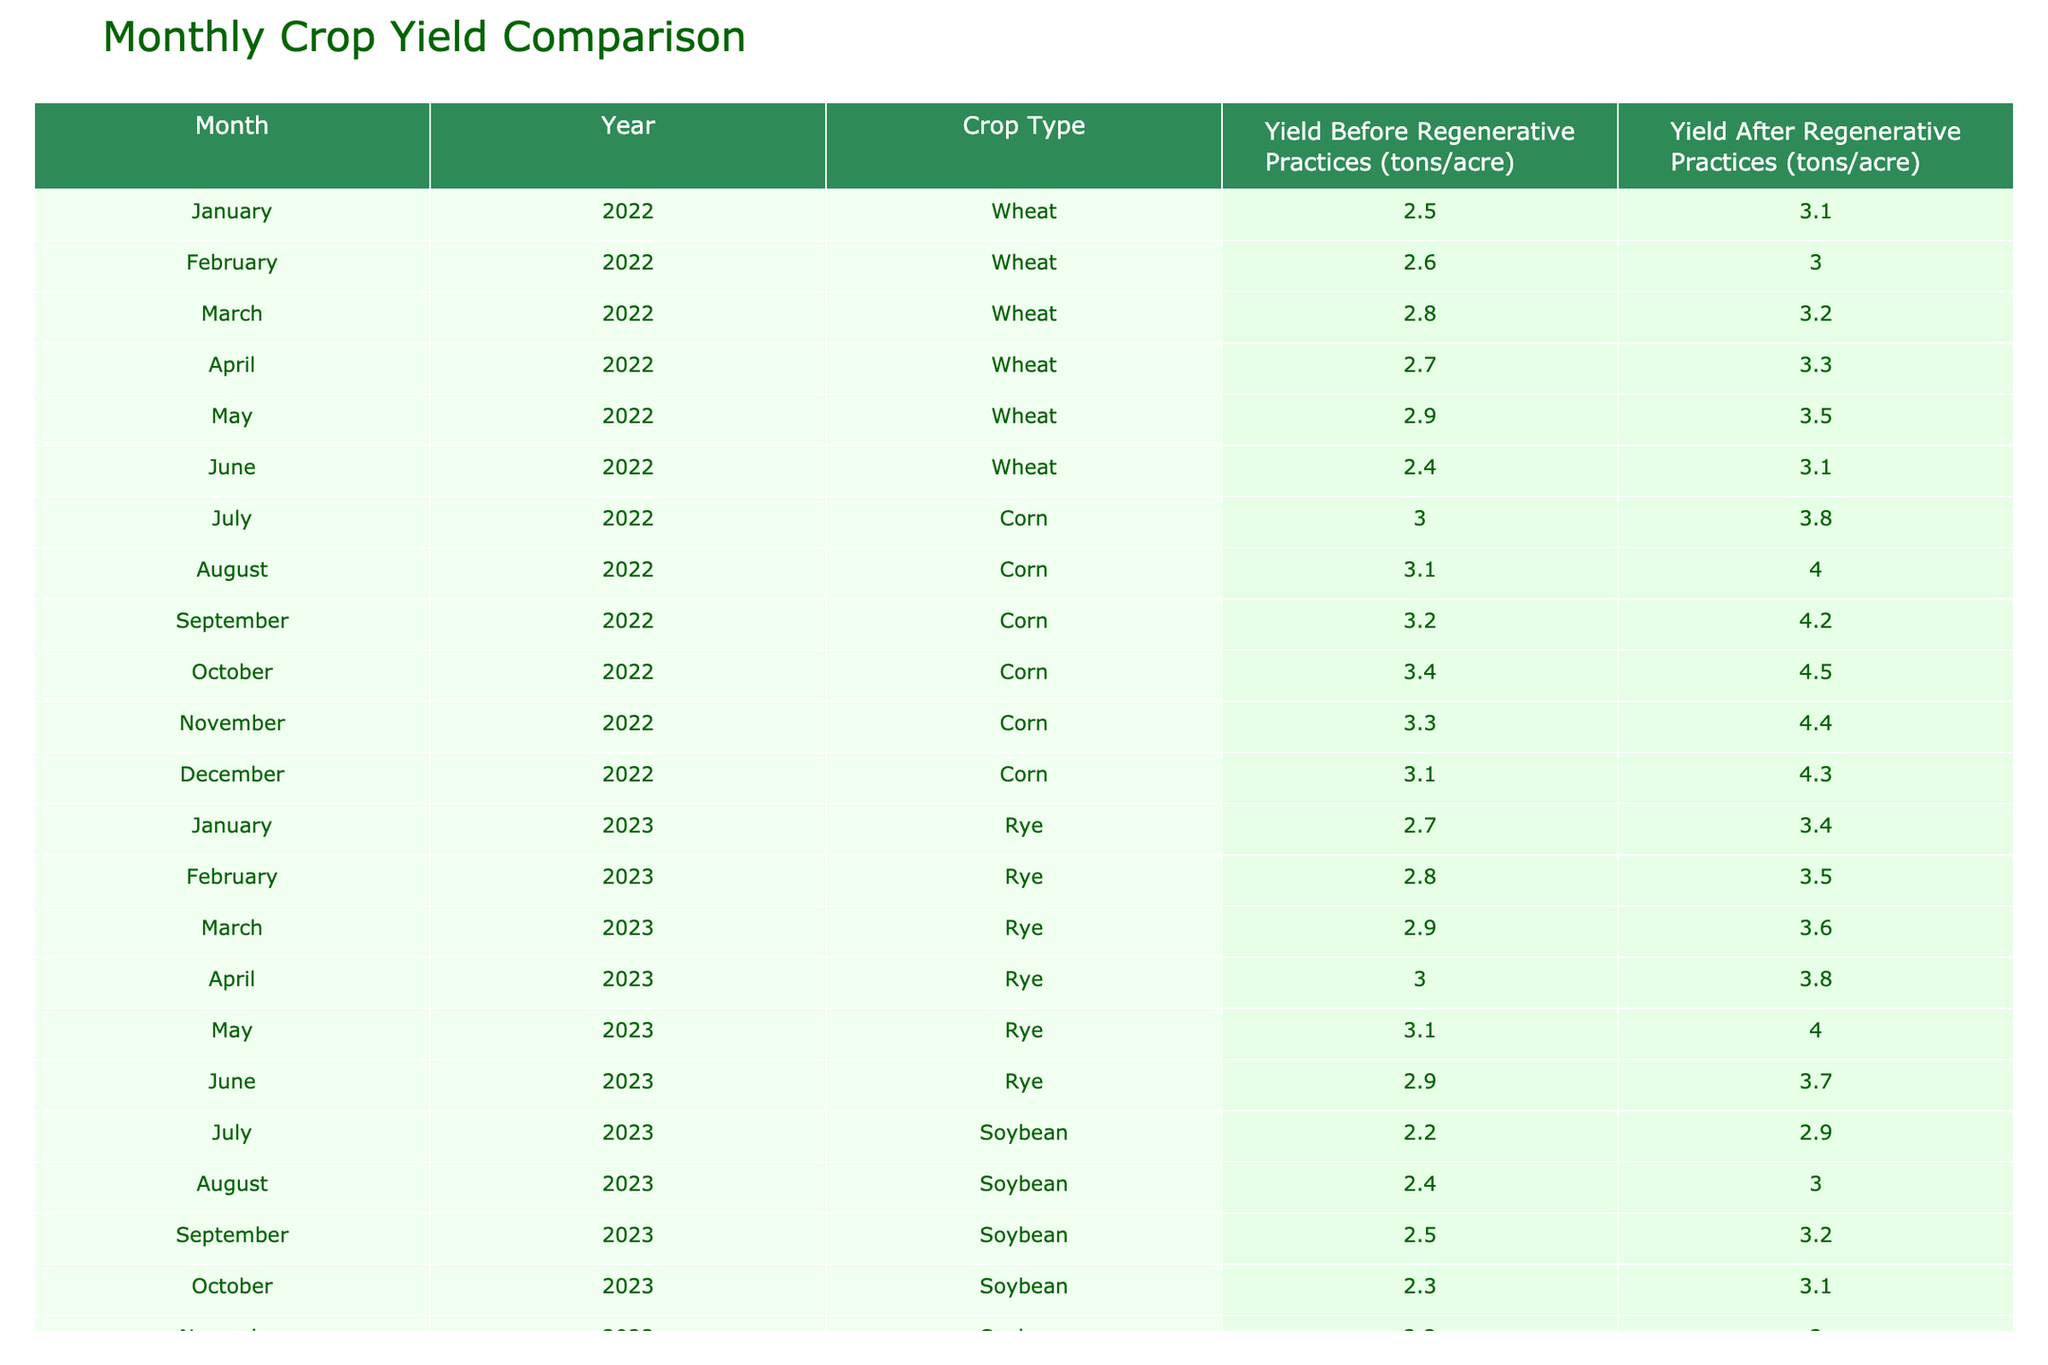What was the yield of Corn in October 2022 before adopting regenerative practices? According to the table, the yield of Corn before regenerative practices was 3.4 tons per acre in October 2022.
Answer: 3.4 What is the difference in yield for Wheat from January 2022 to April 2022 after adopting regenerative practices? The yield of Wheat in January 2022 after regenerative practices was 3.1 tons per acre, and in April 2022 it was 3.3 tons per acre. The difference is calculated as 3.3 - 3.1 = 0.2 tons per acre.
Answer: 0.2 Was the yield of Rye consistently increasing from January 2023 to May 2023 after adopting regenerative practices? The yields of Rye after regenerative practices were 3.4, 3.5, 3.6, 3.8, and 4.0 tons per acre from January to May 2023. Since each subsequent month's yield is higher than the previous, it indicates a consistent increase.
Answer: Yes What is the average yield of Soybean after adopting regenerative practices from July 2023 to December 2023? The yields of Soybean after regenerative practices were 2.9, 3.0, 3.2, 3.1, 3.0, and 3.1 tons per acre from July to December 2023. To find the average: (2.9 + 3.0 + 3.2 + 3.1 + 3.0 + 3.1) = 18.3 tons; then divide by 6 (number of months), which gives 18.3 / 6 = 3.05 tons per acre.
Answer: 3.05 Did the yield for Corn show a decrease at any point between July 2022 and December 2022 after adopting regenerative practices? Looking at the data for Corn, the yields for July through October are 3.8, 4.0, 4.2, and 4.5 tons per acre, all of which show an increase. However, in November 2022 it was 4.4 tons, which is a decrease from October's 4.5 tons. Thus, yes, there was a decrease.
Answer: Yes 